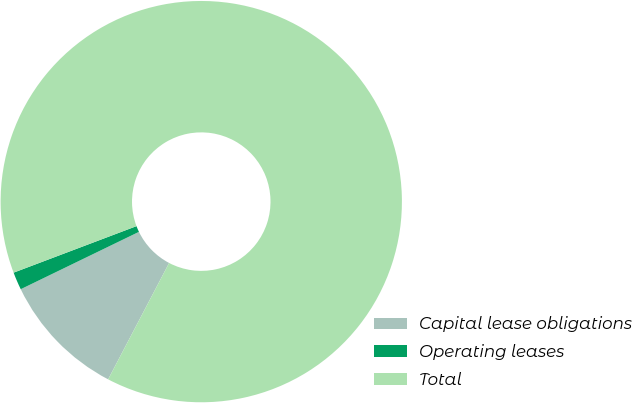<chart> <loc_0><loc_0><loc_500><loc_500><pie_chart><fcel>Capital lease obligations<fcel>Operating leases<fcel>Total<nl><fcel>10.13%<fcel>1.43%<fcel>88.45%<nl></chart> 